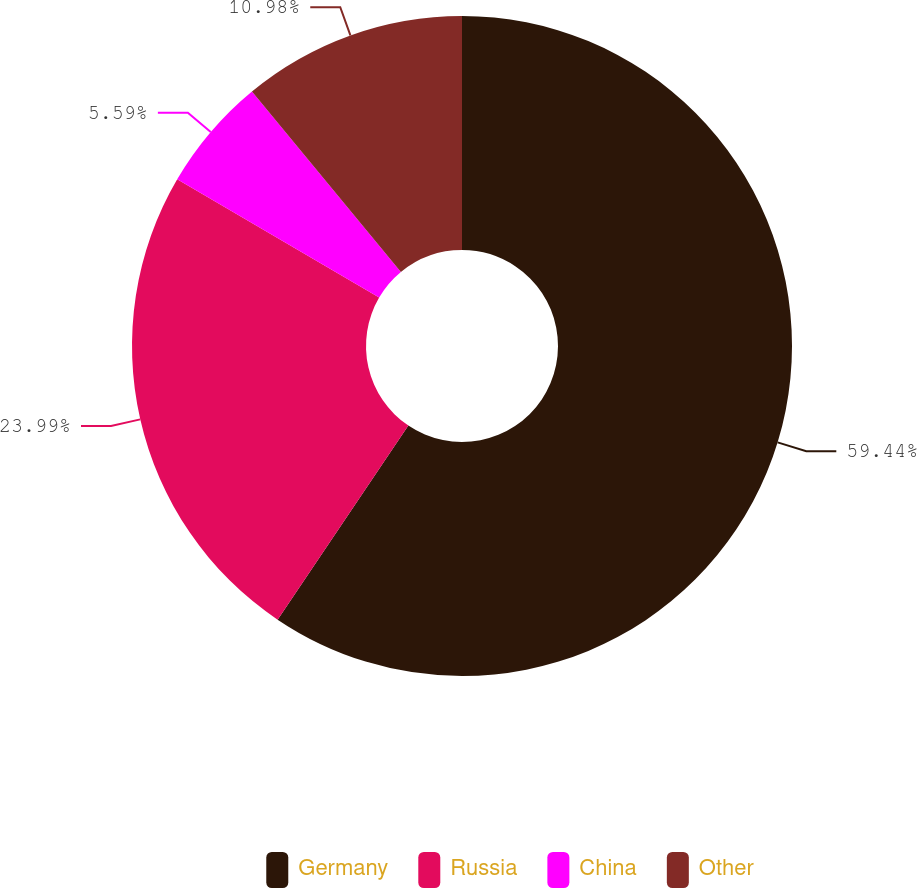<chart> <loc_0><loc_0><loc_500><loc_500><pie_chart><fcel>Germany<fcel>Russia<fcel>China<fcel>Other<nl><fcel>59.43%<fcel>23.99%<fcel>5.59%<fcel>10.98%<nl></chart> 